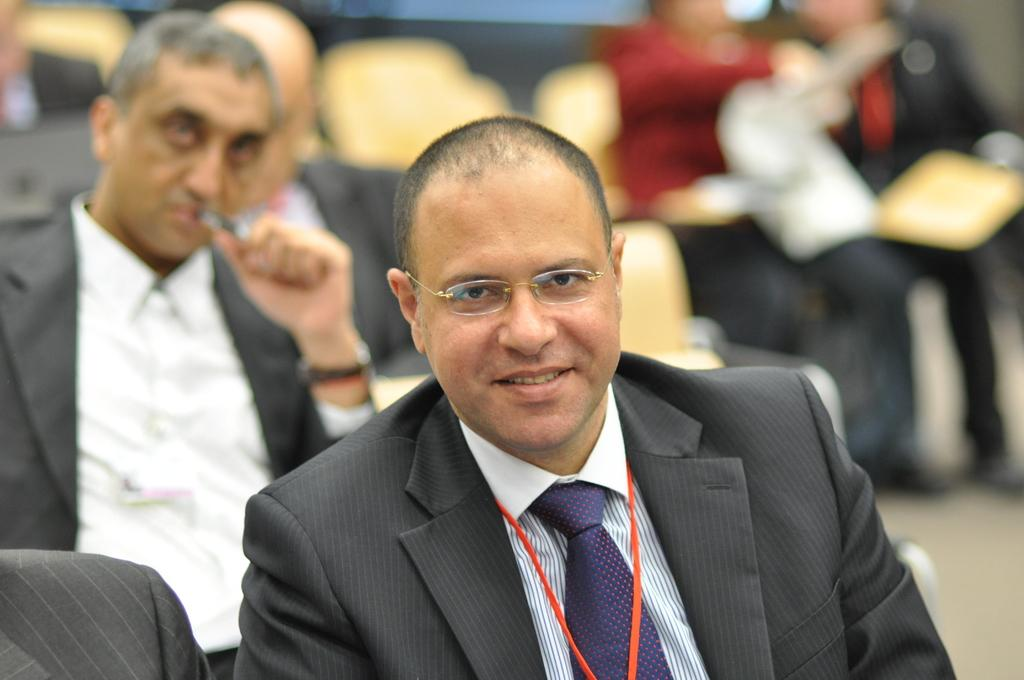What are the people in the image doing? The people in the image are sitting on chairs. Can you describe the clothing of one of the people? One person is wearing a black and white dress and a purple tie. How would you describe the background of the image? The background of the image is blurred. What type of punishment is being administered to the farmer in the image? There is no farmer or punishment present in the image. 